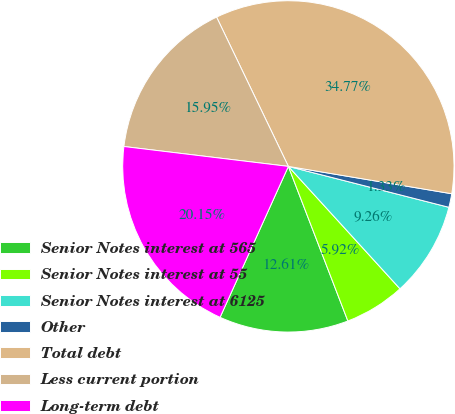Convert chart. <chart><loc_0><loc_0><loc_500><loc_500><pie_chart><fcel>Senior Notes interest at 565<fcel>Senior Notes interest at 55<fcel>Senior Notes interest at 6125<fcel>Other<fcel>Total debt<fcel>Less current portion<fcel>Long-term debt<nl><fcel>12.61%<fcel>5.92%<fcel>9.26%<fcel>1.33%<fcel>34.77%<fcel>15.95%<fcel>20.15%<nl></chart> 